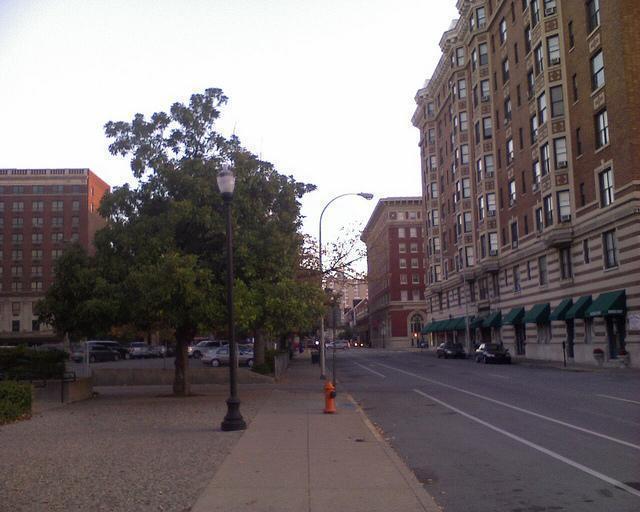During which season are the cars on this street parked?
Choose the correct response, then elucidate: 'Answer: answer
Rationale: rationale.'
Options: Winter, spring, summer, fall. Answer: fall.
Rationale: The season is fall. 